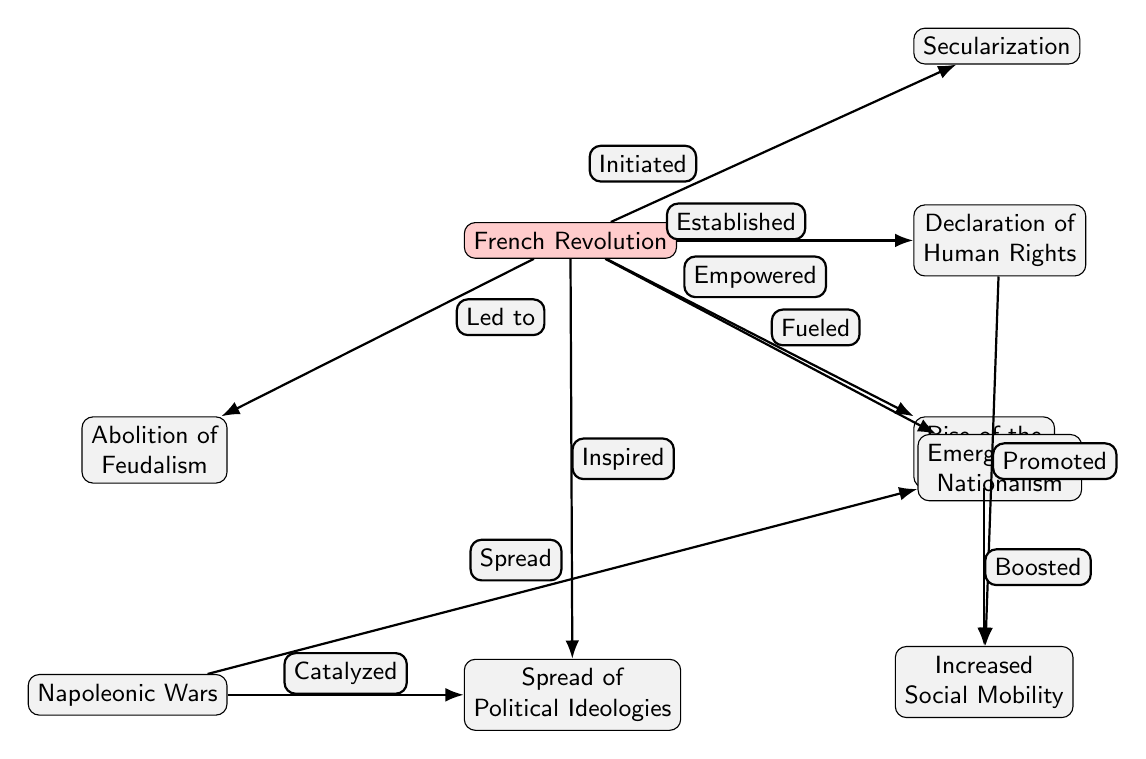What is the influence that led to the abolition of feudalism? The diagram indicates that the French Revolution led to the abolition of feudalism as a result of its foundational changes to social structure.
Answer: French Revolution What node is directly to the right of the French Revolution? In the diagram, the node that is positioned directly to the right of the French Revolution is the Declaration of Human Rights.
Answer: Declaration of Human Rights How many primary influences are listed as being a result of the French Revolution? The diagram shows a total of 7 primary influences stemming from the French Revolution.
Answer: 7 What relationship is defined between the rise of the bourgeoisie and increased social mobility? The diagram indicates that the rise of the bourgeoisie boosted social mobility, revealing a positive causal relationship.
Answer: Boosted What event catalyzed the spread of political ideologies according to the diagram? The diagram explicitly states that the Napoleonic Wars catalyzed the spread of political ideologies, highlighting the impact of military conflicts on political thought.
Answer: Napoleonic Wars Which two concepts are promoted by the Declaration of Human Rights? According to the diagram, the Declaration of Human Rights promotes increased social mobility and individual rights, connecting these social changes to human rights advancements.
Answer: Increased Social Mobility What is the direct consequence of the French Revolution that inspired nationalistic movements? The diagram specifies that the French Revolution fueled nationalism, showing a direct impact on the rise of nationalistic sentiments across Europe.
Answer: Fueled What does the diagram imply about the relationship between wars and nationalism? The diagram reveals that the wars spread nationalism, suggesting a historical link between conflict and the emergence of national identities.
Answer: Spread What did the French Revolution initiate related to religious structures? The diagram illustrates that the French Revolution initiated secularization, denoting a significant shift from traditional religious influences on society.
Answer: Secularization 